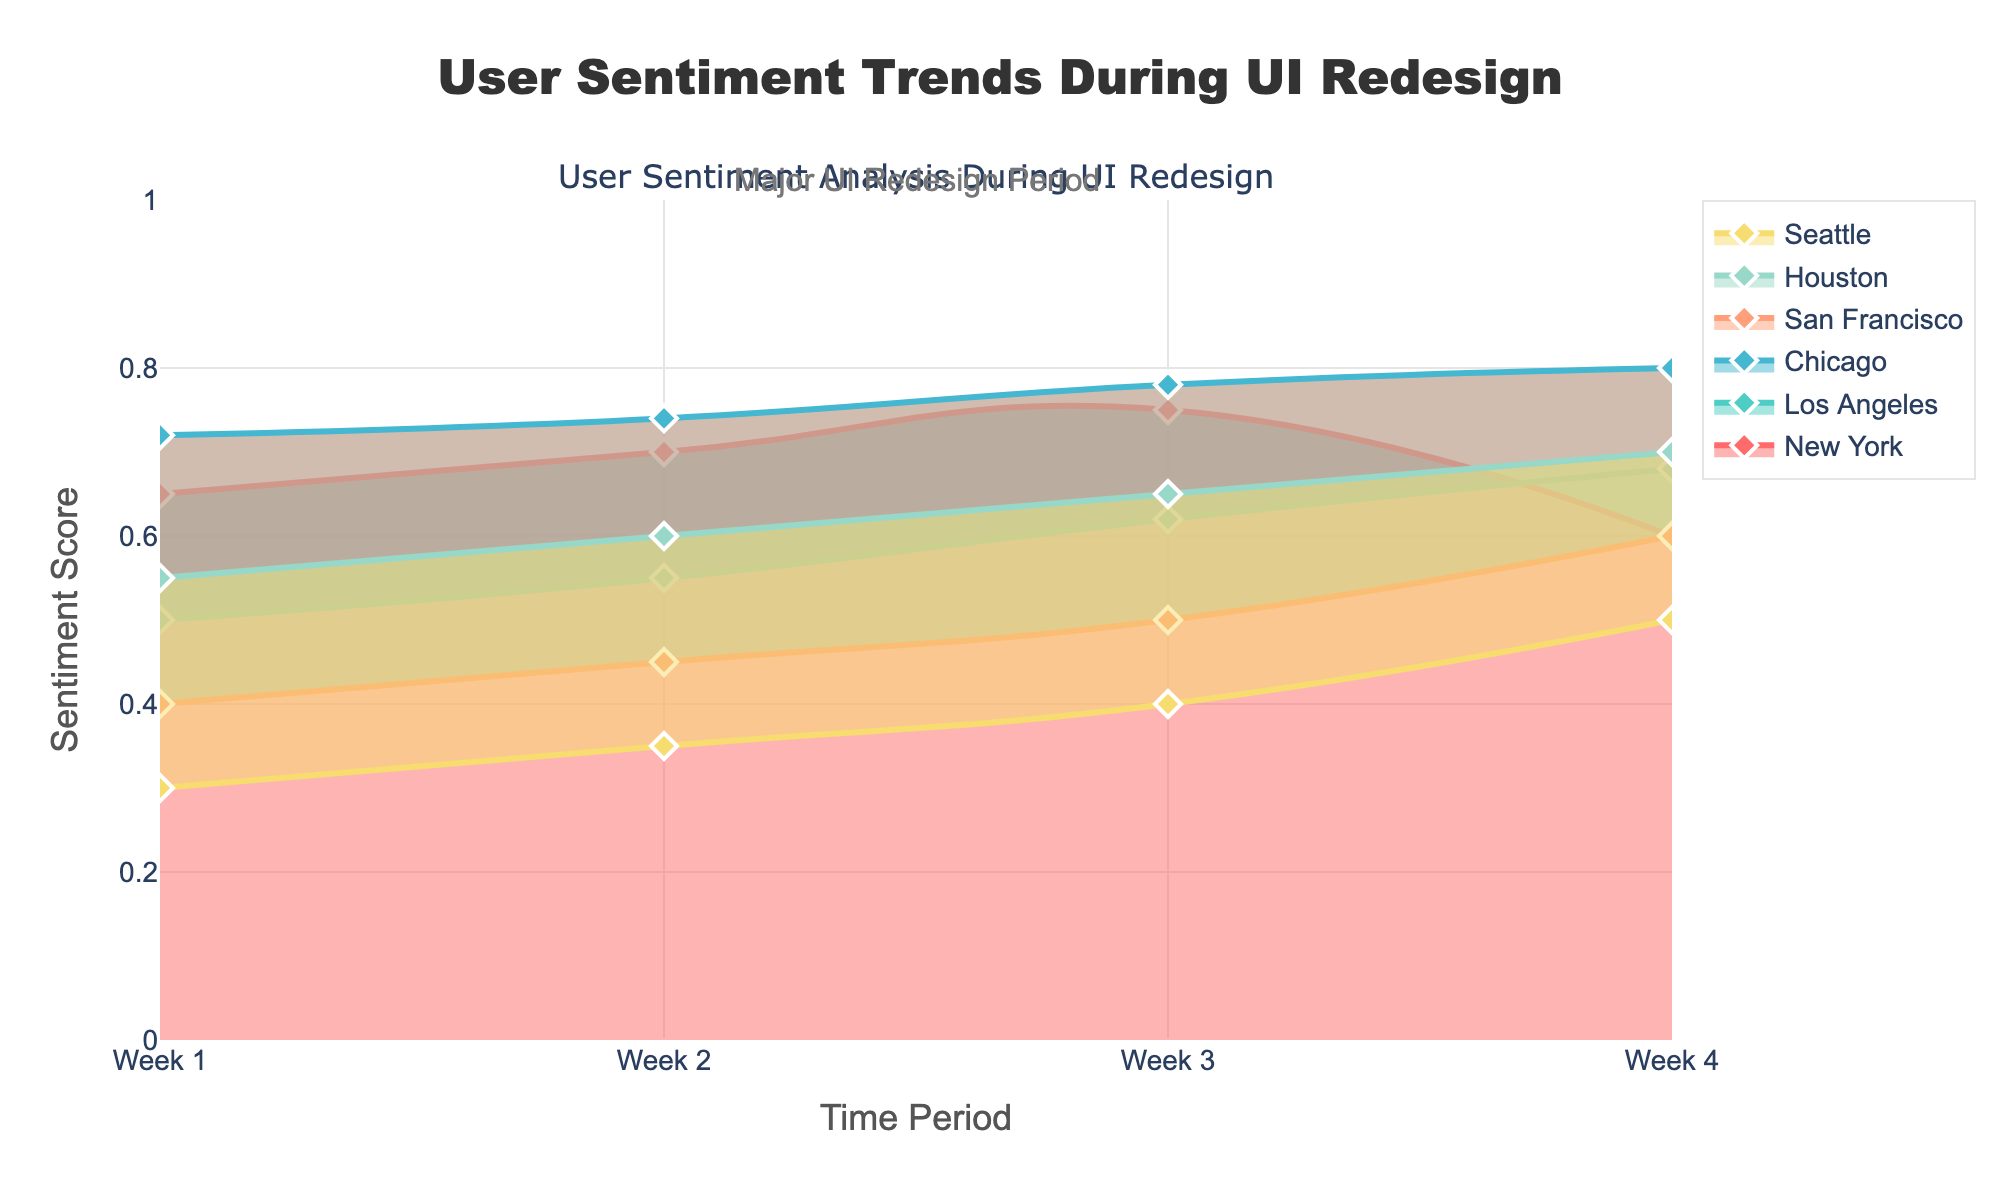How does the sentiment score trend for users in Seattle change over the 4 weeks? By examining the curve for Seattle on the figure, we can see that the sentiment scores start at 0.30 in Week 1, then increase gradually to 0.35 in Week 2, 0.40 in Week 3, and finally reach 0.50 in Week 4.
Answer: Sentiment scores consistently increase Which location experienced the highest sentiment score in any week, and what was that score? From the figure, Chicago clearly has the highest sentiment score in Week 4, where the score reaches 0.80.
Answer: Chicago, 0.80 Compare the sentiment trend between New York and San Francisco. Who had a more significant increase from Week 1 to Week 4? For New York, the sentiment score starts at 0.65 in Week 1 and decreases to 0.60 by Week 4, while San Francisco starts at 0.40 in Week 1 and increases to 0.60 by Week 4. The increase for San Francisco is 0.20, whereas New York actually sees a decrease of 0.05.
Answer: San Francisco What is the average sentiment score for Houston across the entire period? The sentiment scores for Houston over the weeks are 0.55, 0.60, 0.65, and 0.70. Summing these scores gives 2.50. Dividing by the number of weeks (4) gives an average of 0.625.
Answer: 0.625 Identify the smallest sentiment score recorded and the location and week in which it occurred. By examining the figure, the smallest sentiment score is 0.30 for Seattle in Week 1.
Answer: Seattle, Week 1, 0.30 Are there any locations where user sentiment decreased from Week 3 to Week 4? By inspecting the curves closely, only New York's sentiment score drops from 0.75 in Week 3 to 0.60 in Week 4.
Answer: New York Which location had the most significant sentiment improvement during the redesign, and what was the exact change? Comparing all curves, San Francisco had the most significant sentiment improvement, starting at 0.40 in Week 1 and ending at 0.60 in Week 4, giving a change of 0.20.
Answer: San Francisco, 0.20 How do sentiment scores for Los Angeles and Chicago compare at Week 2? At Week 2, the sentiment score for Los Angeles is 0.55 and for Chicago, it is 0.74. Comparing these, Chicago has the higher sentiment score.
Answer: Chicago is higher Which demographic group (by gender) showed overall higher sentiment scores during the redesign? By examining the figures, females (New York, Chicago, and Houston) maintain higher sentiment scores overall compared to males (Los Angeles, San Francisco, Seattle). The highest individual scores occur in the locations where females are the subjects (e.g., Chicago).
Answer: Females 